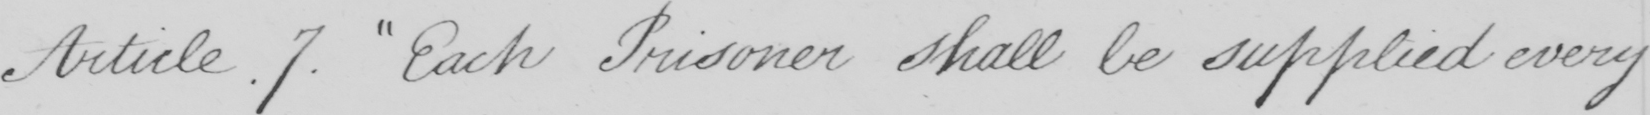Can you tell me what this handwritten text says? Article.7 . Each Prisoner shall be supplied every 